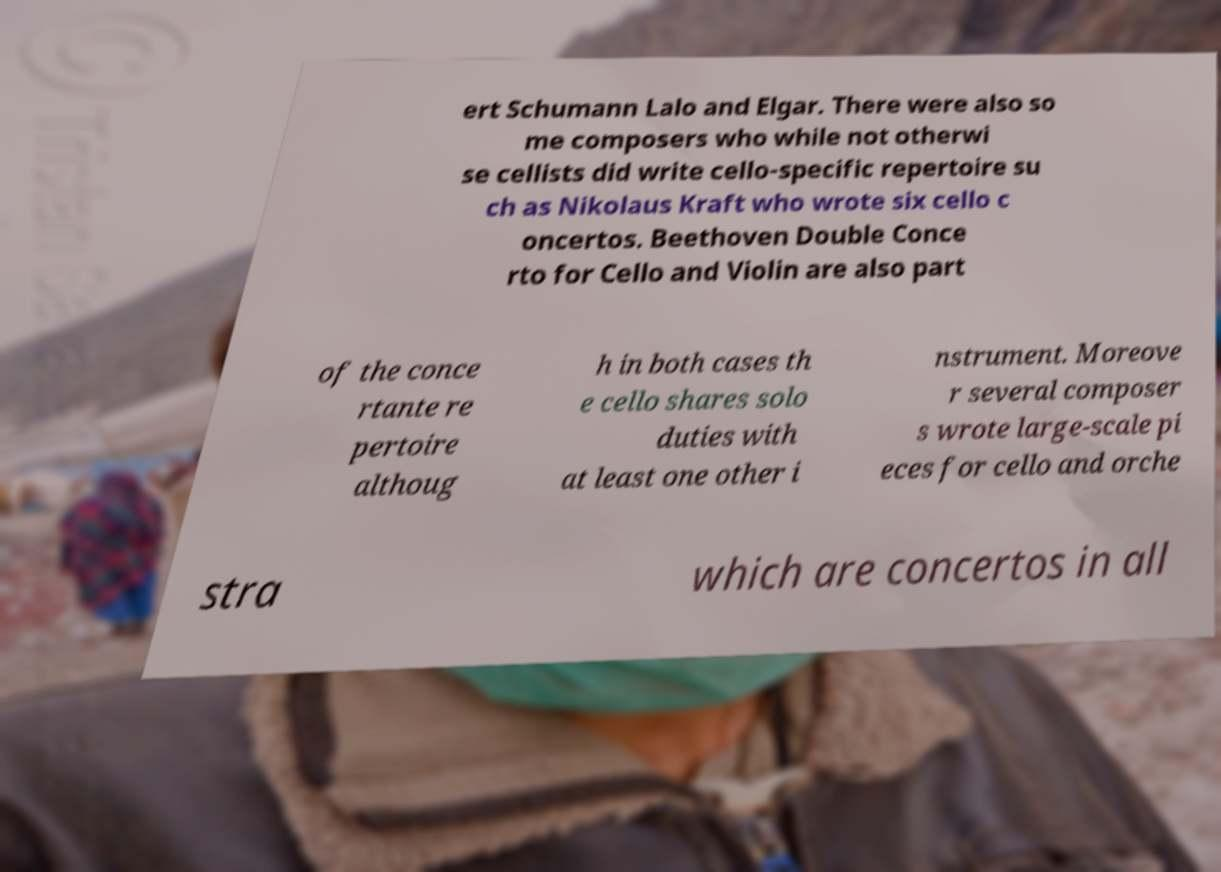There's text embedded in this image that I need extracted. Can you transcribe it verbatim? ert Schumann Lalo and Elgar. There were also so me composers who while not otherwi se cellists did write cello-specific repertoire su ch as Nikolaus Kraft who wrote six cello c oncertos. Beethoven Double Conce rto for Cello and Violin are also part of the conce rtante re pertoire althoug h in both cases th e cello shares solo duties with at least one other i nstrument. Moreove r several composer s wrote large-scale pi eces for cello and orche stra which are concertos in all 